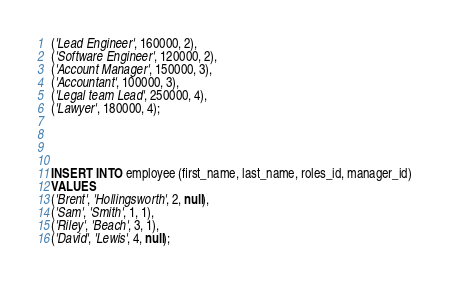<code> <loc_0><loc_0><loc_500><loc_500><_SQL_>('Lead Engineer', 160000, 2),
('Software Engineer', 120000, 2),
('Account Manager', 150000, 3),
('Accountant', 100000, 3),
('Legal team Lead', 250000, 4),
('Lawyer', 180000, 4);




INSERT INTO employee (first_name, last_name, roles_id, manager_id)
VALUES
('Brent', 'Hollingsworth', 2, null),
('Sam', 'Smith', 1, 1),
('Riley', 'Beach', 3, 1),
('David', 'Lewis', 4, null);












</code> 